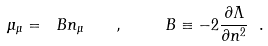Convert formula to latex. <formula><loc_0><loc_0><loc_500><loc_500>\mu _ { \mu } = \ B n _ { \mu } \quad , \quad \ B \equiv - 2 \frac { \partial \Lambda } { \partial n ^ { 2 } } \ .</formula> 